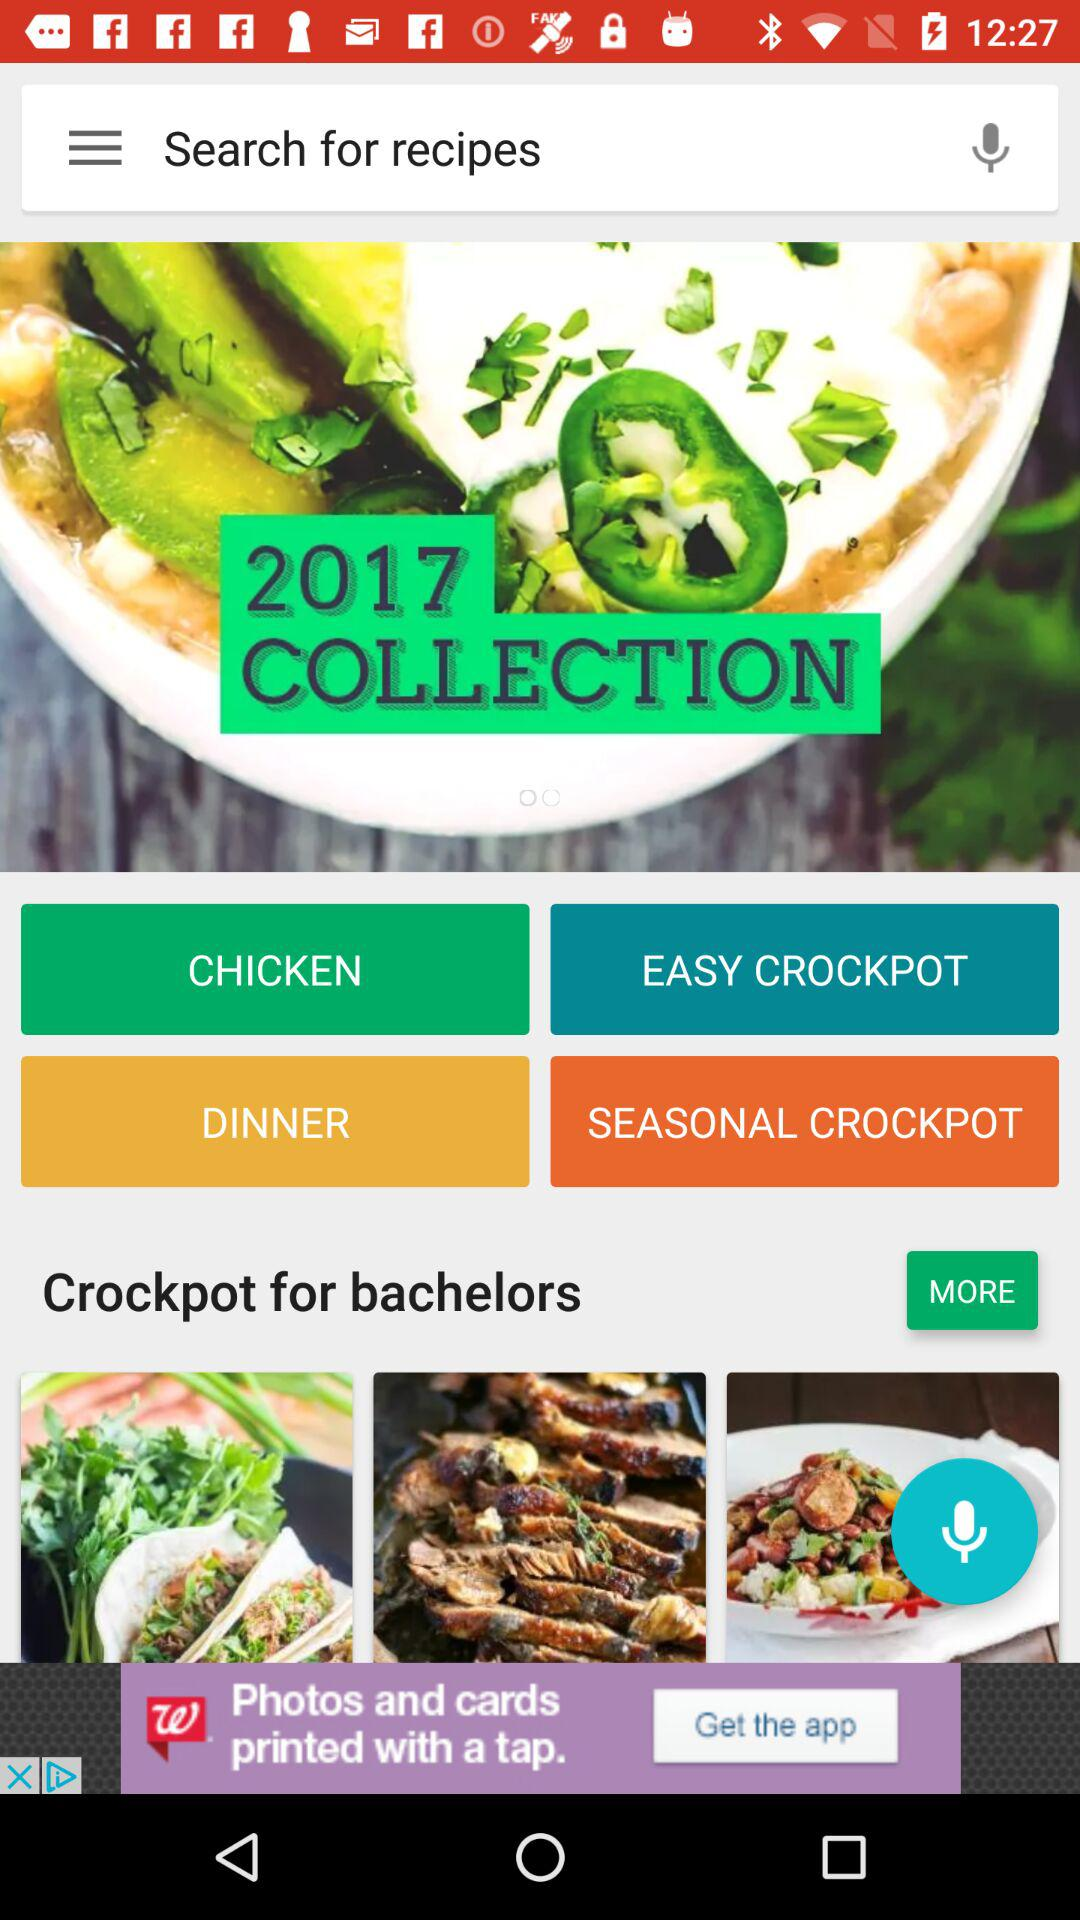Which year's collection is this? This is the collection for the 2017 year. 